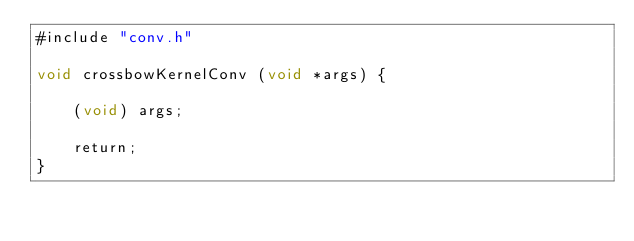<code> <loc_0><loc_0><loc_500><loc_500><_Cuda_>#include "conv.h"

void crossbowKernelConv (void *args) {

	(void) args;

	return;
}
</code> 